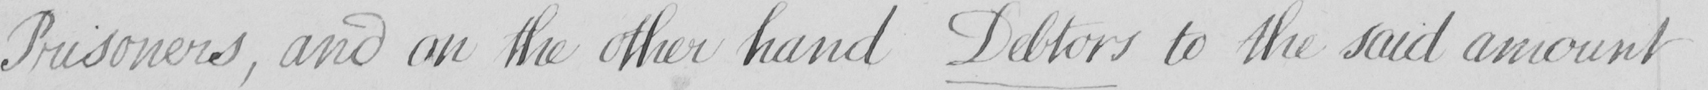Please provide the text content of this handwritten line. Prisoners , and on the other hand Debtors to the said amount 